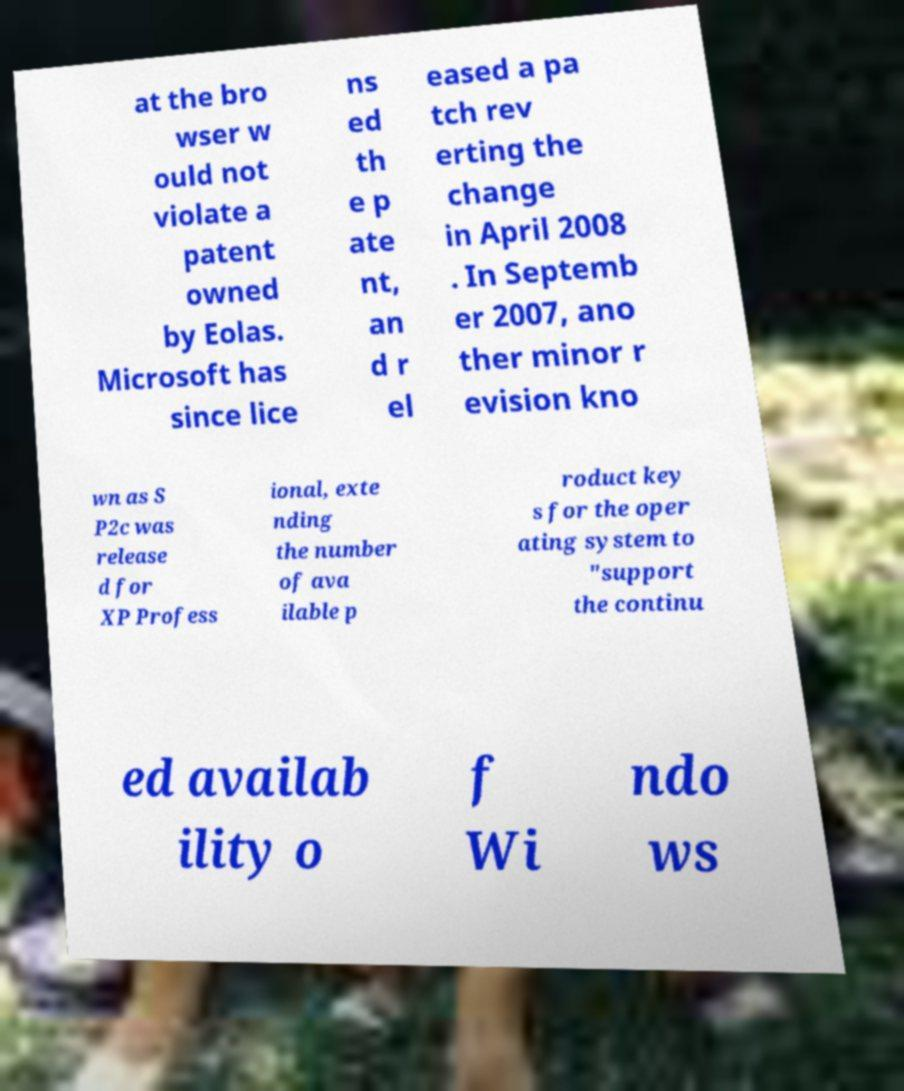Could you extract and type out the text from this image? at the bro wser w ould not violate a patent owned by Eolas. Microsoft has since lice ns ed th e p ate nt, an d r el eased a pa tch rev erting the change in April 2008 . In Septemb er 2007, ano ther minor r evision kno wn as S P2c was release d for XP Profess ional, exte nding the number of ava ilable p roduct key s for the oper ating system to "support the continu ed availab ility o f Wi ndo ws 